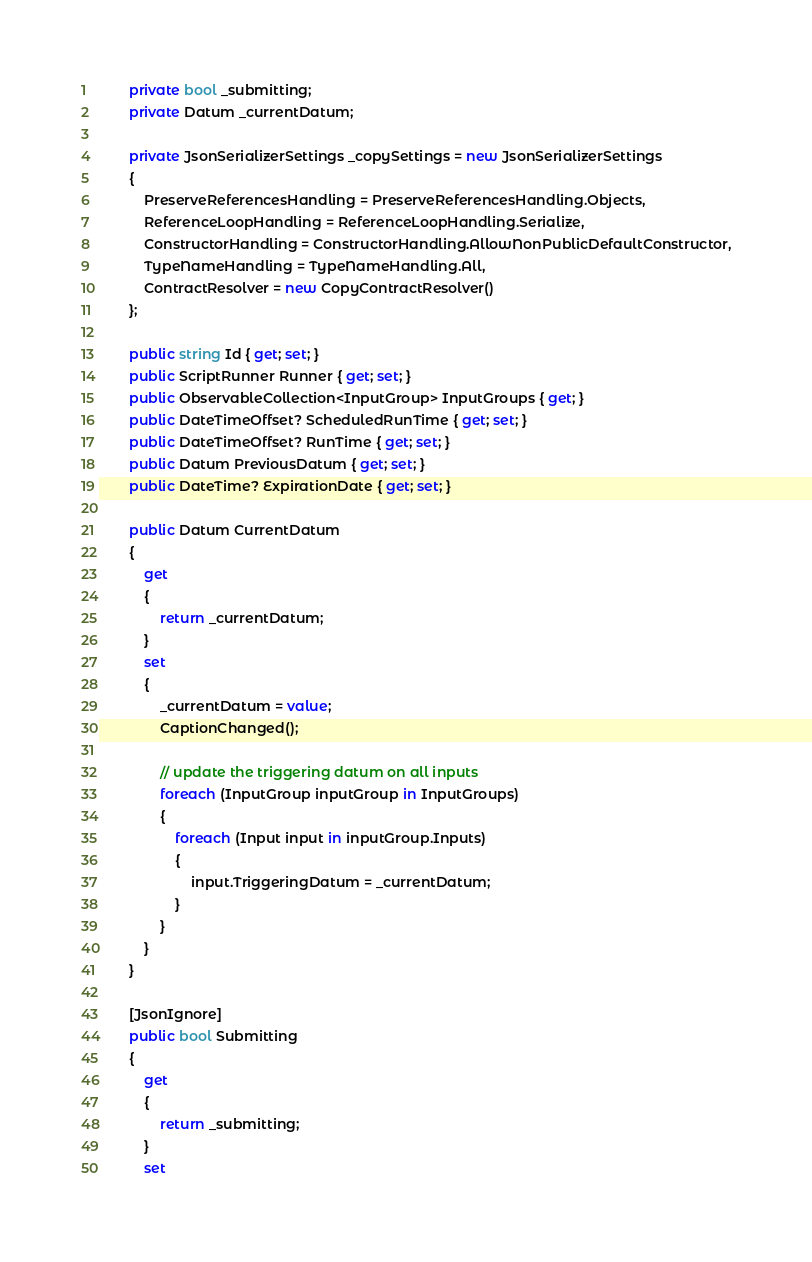<code> <loc_0><loc_0><loc_500><loc_500><_C#_>        private bool _submitting;
        private Datum _currentDatum;

        private JsonSerializerSettings _copySettings = new JsonSerializerSettings
        {
            PreserveReferencesHandling = PreserveReferencesHandling.Objects,
            ReferenceLoopHandling = ReferenceLoopHandling.Serialize,
            ConstructorHandling = ConstructorHandling.AllowNonPublicDefaultConstructor,
            TypeNameHandling = TypeNameHandling.All,
            ContractResolver = new CopyContractResolver()
        };

        public string Id { get; set; }
        public ScriptRunner Runner { get; set; }
        public ObservableCollection<InputGroup> InputGroups { get; }
        public DateTimeOffset? ScheduledRunTime { get; set; }
        public DateTimeOffset? RunTime { get; set; }
        public Datum PreviousDatum { get; set; }
        public DateTime? ExpirationDate { get; set; }

        public Datum CurrentDatum
        {
            get
            {
                return _currentDatum;
            }
            set
            {
                _currentDatum = value;
                CaptionChanged();

                // update the triggering datum on all inputs
                foreach (InputGroup inputGroup in InputGroups)
                {
                    foreach (Input input in inputGroup.Inputs)
                    {
                        input.TriggeringDatum = _currentDatum;
                    }
                }
            }
        }

        [JsonIgnore]
        public bool Submitting
        {
            get
            {
                return _submitting;
            }
            set</code> 